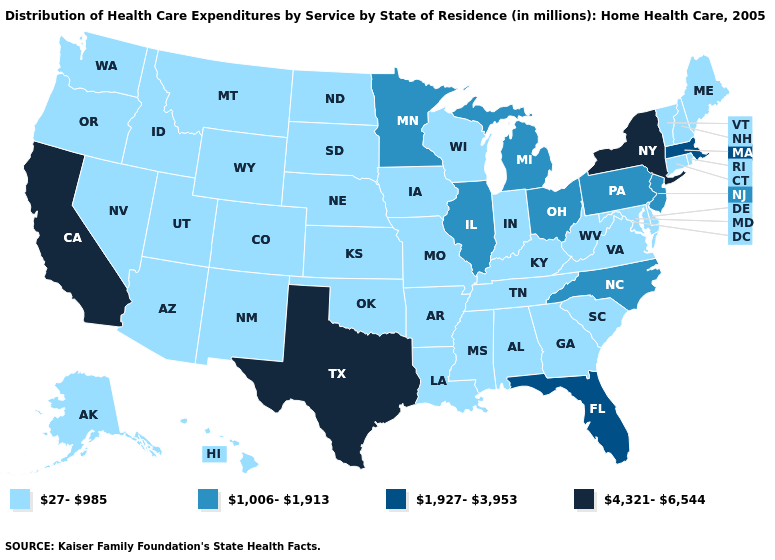Name the states that have a value in the range 1,006-1,913?
Answer briefly. Illinois, Michigan, Minnesota, New Jersey, North Carolina, Ohio, Pennsylvania. Among the states that border Maine , which have the lowest value?
Write a very short answer. New Hampshire. Does the first symbol in the legend represent the smallest category?
Answer briefly. Yes. Is the legend a continuous bar?
Keep it brief. No. Does Texas have the same value as California?
Write a very short answer. Yes. Name the states that have a value in the range 4,321-6,544?
Short answer required. California, New York, Texas. What is the lowest value in the USA?
Answer briefly. 27-985. What is the value of California?
Concise answer only. 4,321-6,544. What is the highest value in the MidWest ?
Be succinct. 1,006-1,913. Which states hav the highest value in the South?
Keep it brief. Texas. What is the lowest value in the Northeast?
Give a very brief answer. 27-985. Name the states that have a value in the range 27-985?
Give a very brief answer. Alabama, Alaska, Arizona, Arkansas, Colorado, Connecticut, Delaware, Georgia, Hawaii, Idaho, Indiana, Iowa, Kansas, Kentucky, Louisiana, Maine, Maryland, Mississippi, Missouri, Montana, Nebraska, Nevada, New Hampshire, New Mexico, North Dakota, Oklahoma, Oregon, Rhode Island, South Carolina, South Dakota, Tennessee, Utah, Vermont, Virginia, Washington, West Virginia, Wisconsin, Wyoming. Name the states that have a value in the range 4,321-6,544?
Answer briefly. California, New York, Texas. What is the value of New Mexico?
Short answer required. 27-985. Name the states that have a value in the range 1,006-1,913?
Concise answer only. Illinois, Michigan, Minnesota, New Jersey, North Carolina, Ohio, Pennsylvania. 